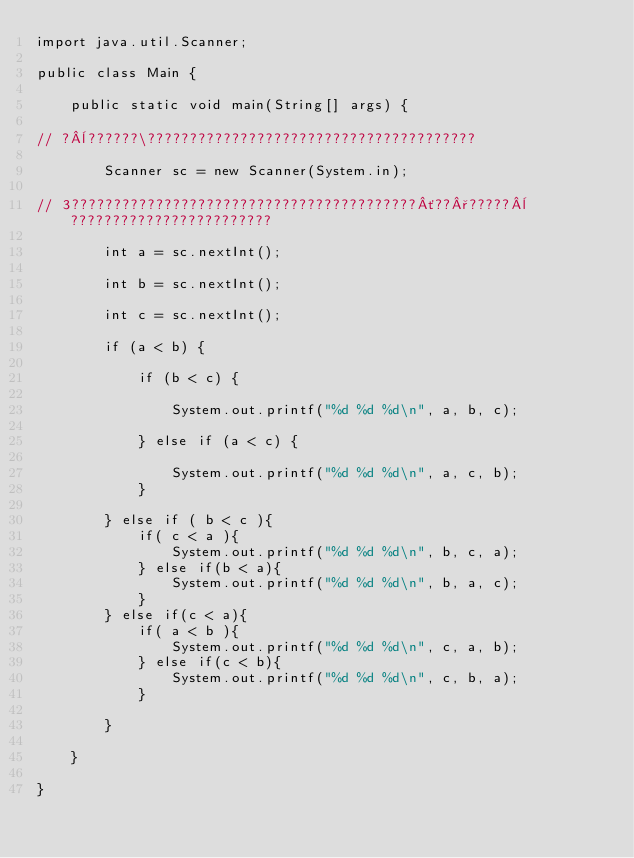Convert code to text. <code><loc_0><loc_0><loc_500><loc_500><_Java_>import java.util.Scanner;

public class Main {

    public static void main(String[] args) {

// ?¨??????\???????????????????????????????????????

        Scanner sc = new Scanner(System.in);

// 3?????????????????????????????????????????´??°?????¨????????????????????????

        int a = sc.nextInt();

        int b = sc.nextInt();

        int c = sc.nextInt();

        if (a < b) {

            if (b < c) {

                System.out.printf("%d %d %d\n", a, b, c);

            } else if (a < c) {

                System.out.printf("%d %d %d\n", a, c, b);
            }

        } else if ( b < c ){
            if( c < a ){
                System.out.printf("%d %d %d\n", b, c, a);
            } else if(b < a){
                System.out.printf("%d %d %d\n", b, a, c);
            }
        } else if(c < a){
            if( a < b ){
                System.out.printf("%d %d %d\n", c, a, b);
            } else if(c < b){
                System.out.printf("%d %d %d\n", c, b, a);
            }

        }

    }

}</code> 